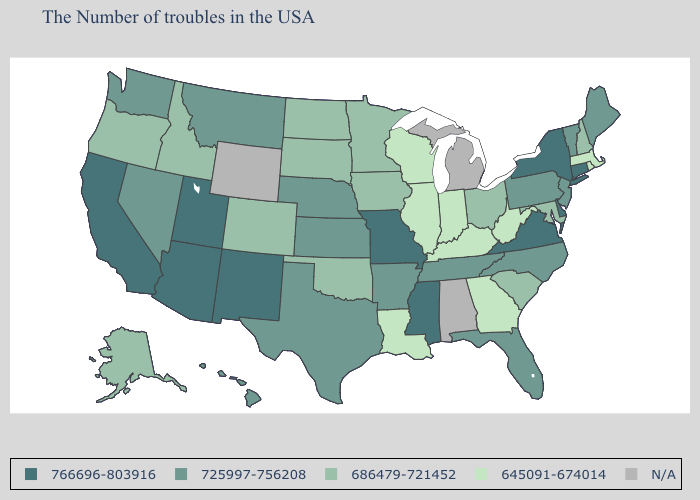Which states have the lowest value in the MidWest?
Quick response, please. Indiana, Wisconsin, Illinois. What is the highest value in states that border Michigan?
Concise answer only. 686479-721452. Name the states that have a value in the range 725997-756208?
Write a very short answer. Maine, Vermont, New Jersey, Pennsylvania, North Carolina, Florida, Tennessee, Arkansas, Kansas, Nebraska, Texas, Montana, Nevada, Washington, Hawaii. Among the states that border Utah , which have the lowest value?
Quick response, please. Colorado, Idaho. What is the value of Kansas?
Concise answer only. 725997-756208. Among the states that border Florida , which have the lowest value?
Answer briefly. Georgia. Name the states that have a value in the range 686479-721452?
Write a very short answer. New Hampshire, Maryland, South Carolina, Ohio, Minnesota, Iowa, Oklahoma, South Dakota, North Dakota, Colorado, Idaho, Oregon, Alaska. Does Utah have the highest value in the USA?
Be succinct. Yes. Which states hav the highest value in the Northeast?
Give a very brief answer. Connecticut, New York. Does Minnesota have the highest value in the MidWest?
Be succinct. No. Name the states that have a value in the range 645091-674014?
Short answer required. Massachusetts, Rhode Island, West Virginia, Georgia, Kentucky, Indiana, Wisconsin, Illinois, Louisiana. What is the value of Pennsylvania?
Short answer required. 725997-756208. Does Iowa have the lowest value in the USA?
Quick response, please. No. What is the value of Arizona?
Give a very brief answer. 766696-803916. 